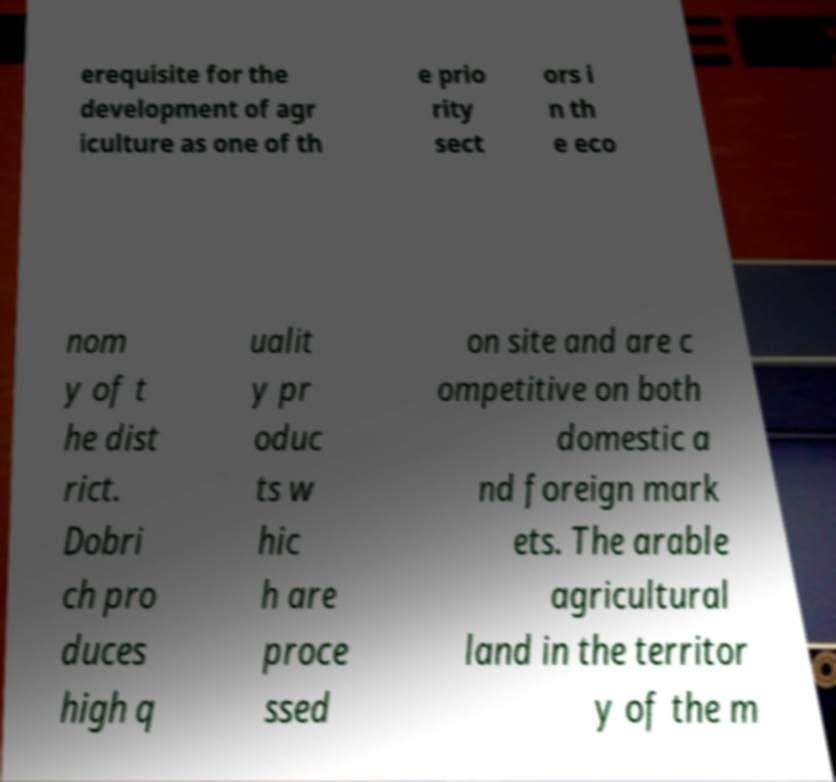Can you read and provide the text displayed in the image?This photo seems to have some interesting text. Can you extract and type it out for me? erequisite for the development of agr iculture as one of th e prio rity sect ors i n th e eco nom y of t he dist rict. Dobri ch pro duces high q ualit y pr oduc ts w hic h are proce ssed on site and are c ompetitive on both domestic a nd foreign mark ets. The arable agricultural land in the territor y of the m 